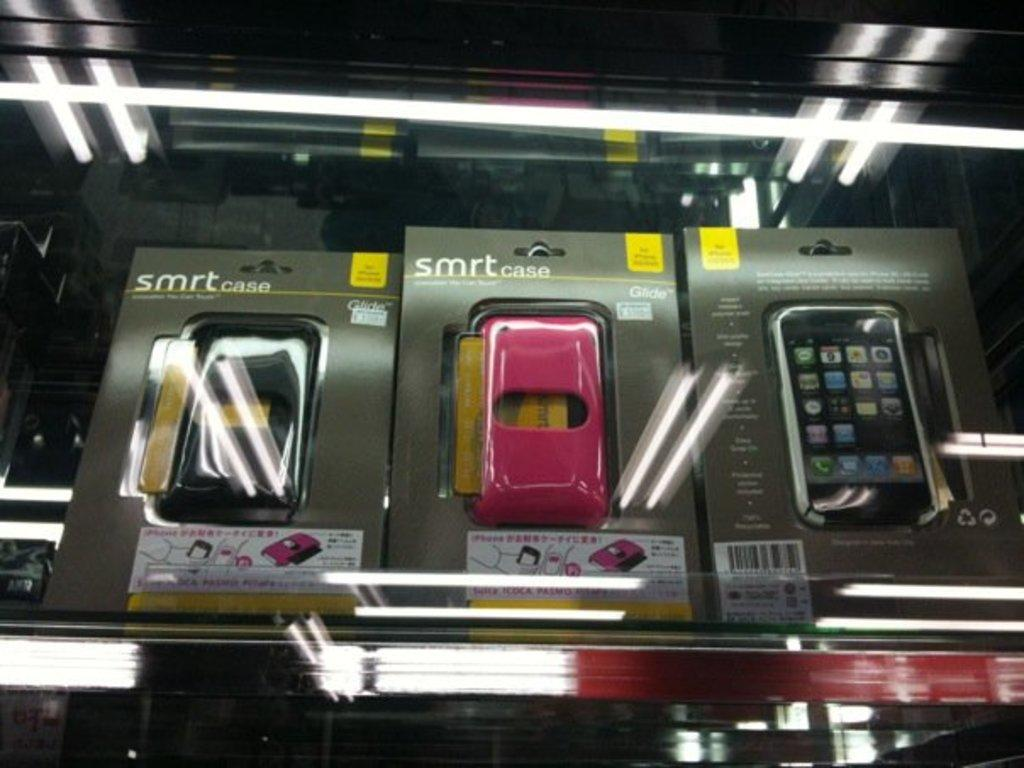<image>
Share a concise interpretation of the image provided. SMRT cases on the shelf are available in black and pink. 